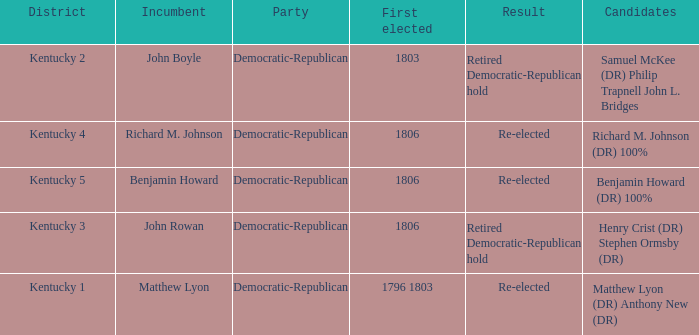Name the first elected for kentucky 3 1806.0. 